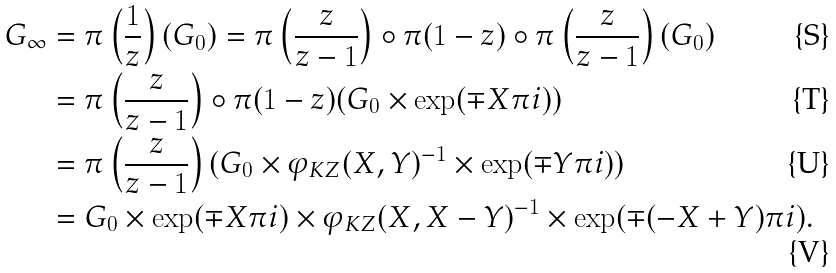<formula> <loc_0><loc_0><loc_500><loc_500>G _ { \infty } & = \pi \left ( \frac { 1 } { z } \right ) ( G _ { 0 } ) = \pi \left ( \frac { z } { z - 1 } \right ) \circ \pi ( 1 - z ) \circ \pi \left ( \frac { z } { z - 1 } \right ) ( G _ { 0 } ) \\ & = \pi \left ( \frac { z } { z - 1 } \right ) \circ \pi ( 1 - z ) ( G _ { 0 } \times \exp ( \mp X \pi i ) ) \\ & = \pi \left ( \frac { z } { z - 1 } \right ) ( G _ { 0 } \times \varphi _ { K Z } ( X , Y ) ^ { - 1 } \times \exp ( \mp Y \pi i ) ) \\ & = G _ { 0 } \times \exp ( \mp X \pi i ) \times \varphi _ { K Z } ( X , X - Y ) ^ { - 1 } \times \exp ( \mp ( - X + Y ) \pi i ) .</formula> 